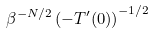Convert formula to latex. <formula><loc_0><loc_0><loc_500><loc_500>\beta ^ { - N / 2 } \left ( - T ^ { \prime } ( 0 ) \right ) ^ { - 1 / 2 }</formula> 